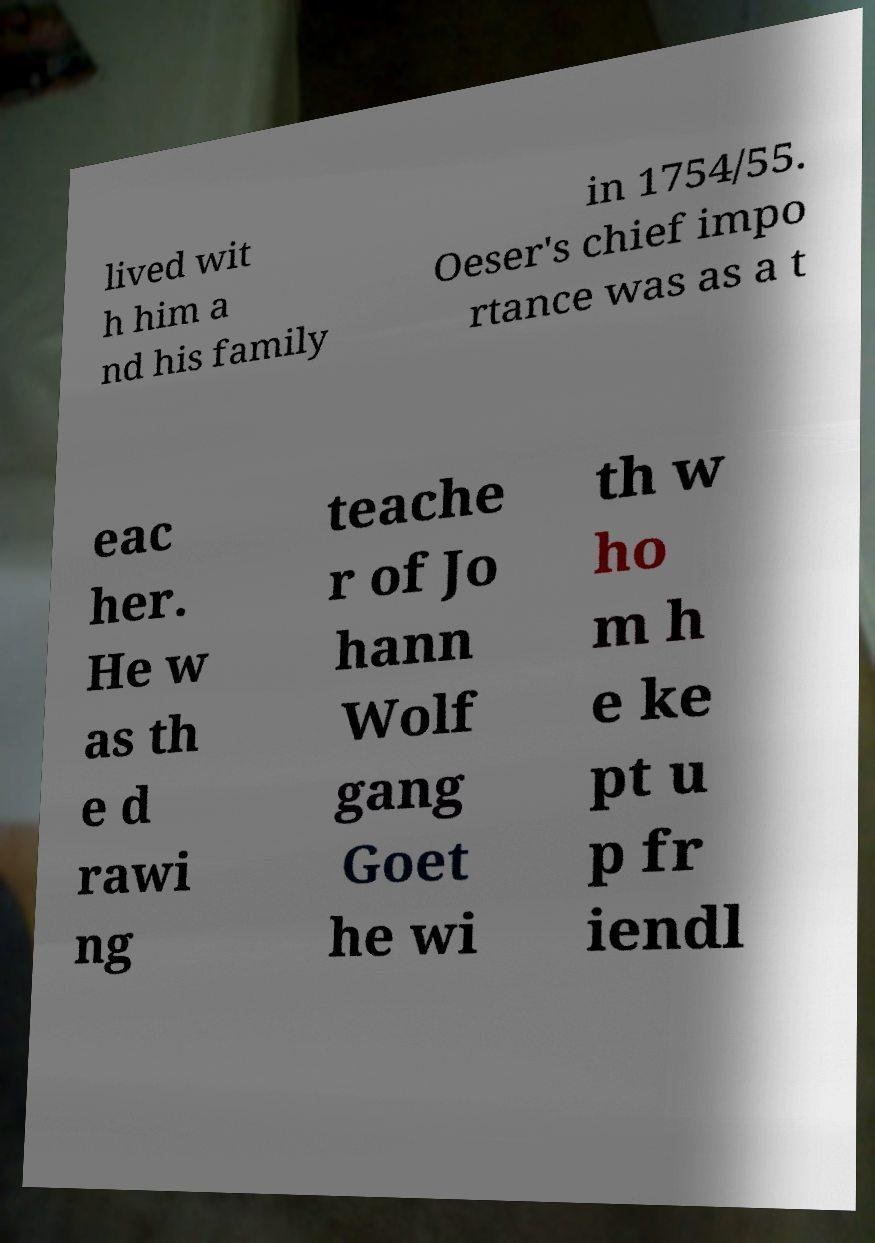Can you read and provide the text displayed in the image?This photo seems to have some interesting text. Can you extract and type it out for me? lived wit h him a nd his family in 1754/55. Oeser's chief impo rtance was as a t eac her. He w as th e d rawi ng teache r of Jo hann Wolf gang Goet he wi th w ho m h e ke pt u p fr iendl 